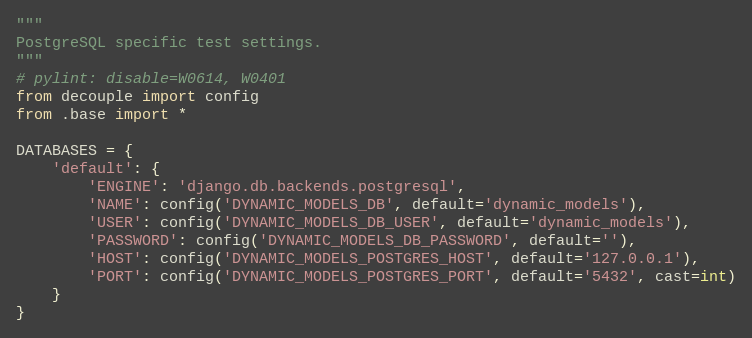Convert code to text. <code><loc_0><loc_0><loc_500><loc_500><_Python_>"""
PostgreSQL specific test settings.
"""
# pylint: disable=W0614, W0401
from decouple import config
from .base import *

DATABASES = {
    'default': {
        'ENGINE': 'django.db.backends.postgresql',
        'NAME': config('DYNAMIC_MODELS_DB', default='dynamic_models'),
        'USER': config('DYNAMIC_MODELS_DB_USER', default='dynamic_models'),
        'PASSWORD': config('DYNAMIC_MODELS_DB_PASSWORD', default=''),
        'HOST': config('DYNAMIC_MODELS_POSTGRES_HOST', default='127.0.0.1'),
        'PORT': config('DYNAMIC_MODELS_POSTGRES_PORT', default='5432', cast=int)
    }
}
</code> 